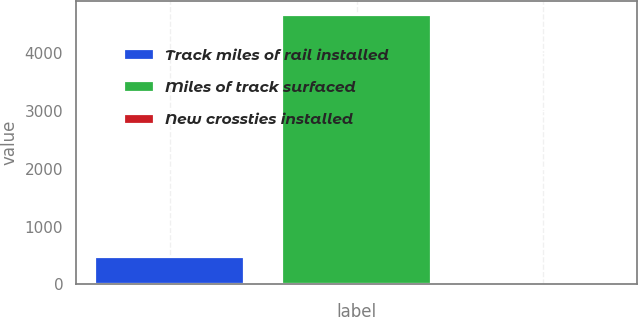Convert chart. <chart><loc_0><loc_0><loc_500><loc_500><bar_chart><fcel>Track miles of rail installed<fcel>Miles of track surfaced<fcel>New crossties installed<nl><fcel>468.55<fcel>4663<fcel>2.5<nl></chart> 